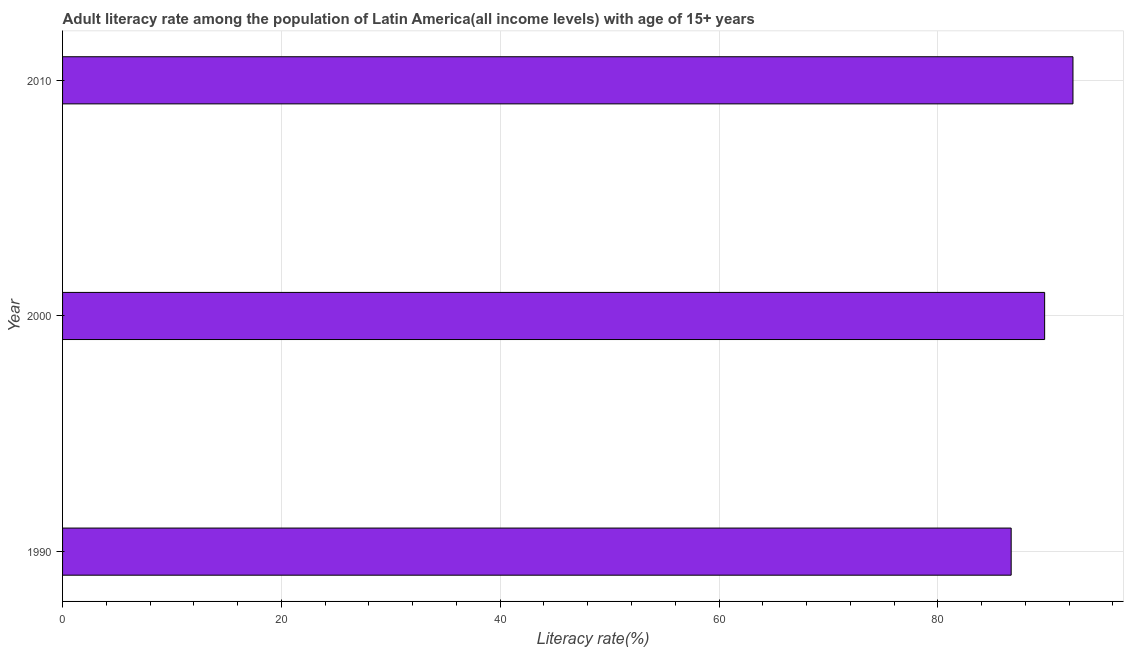Does the graph contain any zero values?
Provide a short and direct response. No. Does the graph contain grids?
Give a very brief answer. Yes. What is the title of the graph?
Ensure brevity in your answer.  Adult literacy rate among the population of Latin America(all income levels) with age of 15+ years. What is the label or title of the X-axis?
Offer a terse response. Literacy rate(%). What is the label or title of the Y-axis?
Your answer should be very brief. Year. What is the adult literacy rate in 2010?
Keep it short and to the point. 92.35. Across all years, what is the maximum adult literacy rate?
Your answer should be very brief. 92.35. Across all years, what is the minimum adult literacy rate?
Offer a terse response. 86.7. In which year was the adult literacy rate minimum?
Keep it short and to the point. 1990. What is the sum of the adult literacy rate?
Provide a short and direct response. 268.81. What is the difference between the adult literacy rate in 1990 and 2010?
Make the answer very short. -5.65. What is the average adult literacy rate per year?
Ensure brevity in your answer.  89.6. What is the median adult literacy rate?
Make the answer very short. 89.76. What is the ratio of the adult literacy rate in 1990 to that in 2000?
Provide a succinct answer. 0.97. Is the adult literacy rate in 1990 less than that in 2000?
Give a very brief answer. Yes. What is the difference between the highest and the second highest adult literacy rate?
Your answer should be compact. 2.59. Is the sum of the adult literacy rate in 1990 and 2000 greater than the maximum adult literacy rate across all years?
Make the answer very short. Yes. What is the difference between the highest and the lowest adult literacy rate?
Keep it short and to the point. 5.65. In how many years, is the adult literacy rate greater than the average adult literacy rate taken over all years?
Your answer should be very brief. 2. How many bars are there?
Offer a very short reply. 3. Are all the bars in the graph horizontal?
Offer a very short reply. Yes. How many years are there in the graph?
Offer a very short reply. 3. What is the Literacy rate(%) in 1990?
Offer a very short reply. 86.7. What is the Literacy rate(%) of 2000?
Your answer should be very brief. 89.76. What is the Literacy rate(%) in 2010?
Your response must be concise. 92.35. What is the difference between the Literacy rate(%) in 1990 and 2000?
Your answer should be very brief. -3.06. What is the difference between the Literacy rate(%) in 1990 and 2010?
Offer a terse response. -5.65. What is the difference between the Literacy rate(%) in 2000 and 2010?
Provide a succinct answer. -2.59. What is the ratio of the Literacy rate(%) in 1990 to that in 2000?
Give a very brief answer. 0.97. What is the ratio of the Literacy rate(%) in 1990 to that in 2010?
Keep it short and to the point. 0.94. What is the ratio of the Literacy rate(%) in 2000 to that in 2010?
Your answer should be compact. 0.97. 